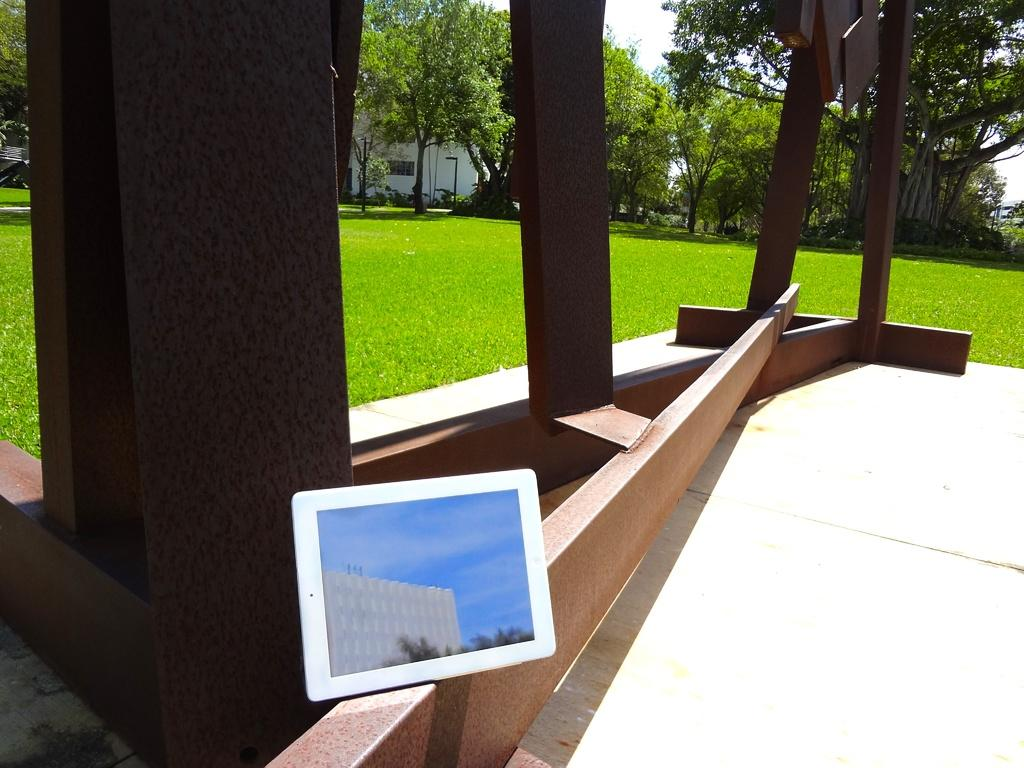What architectural features can be seen in the image? There are pillars in the image. What type of natural elements are visible in the background of the image? There are trees in the background of the image. What is the condition of the sky in the image? The sky is clear and visible in the background of the image. What type of glass can be seen on the hill in the image? There is no hill or glass present in the image. Can you describe the toy that the child is playing with on the left side of the image? There is no child or toy present in the image. 